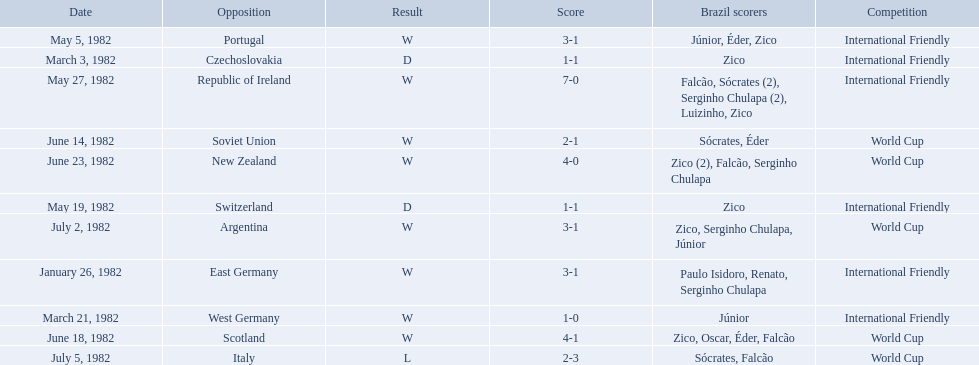What are all the dates of games in 1982 in brazilian football? January 26, 1982, March 3, 1982, March 21, 1982, May 5, 1982, May 19, 1982, May 27, 1982, June 14, 1982, June 18, 1982, June 23, 1982, July 2, 1982, July 5, 1982. Which of these dates is at the top of the chart? January 26, 1982. What are the dates January 26, 1982, March 3, 1982, March 21, 1982, May 5, 1982, May 19, 1982, May 27, 1982, June 14, 1982, June 18, 1982, June 23, 1982, July 2, 1982, July 5, 1982. Which date is at the top? January 26, 1982. 